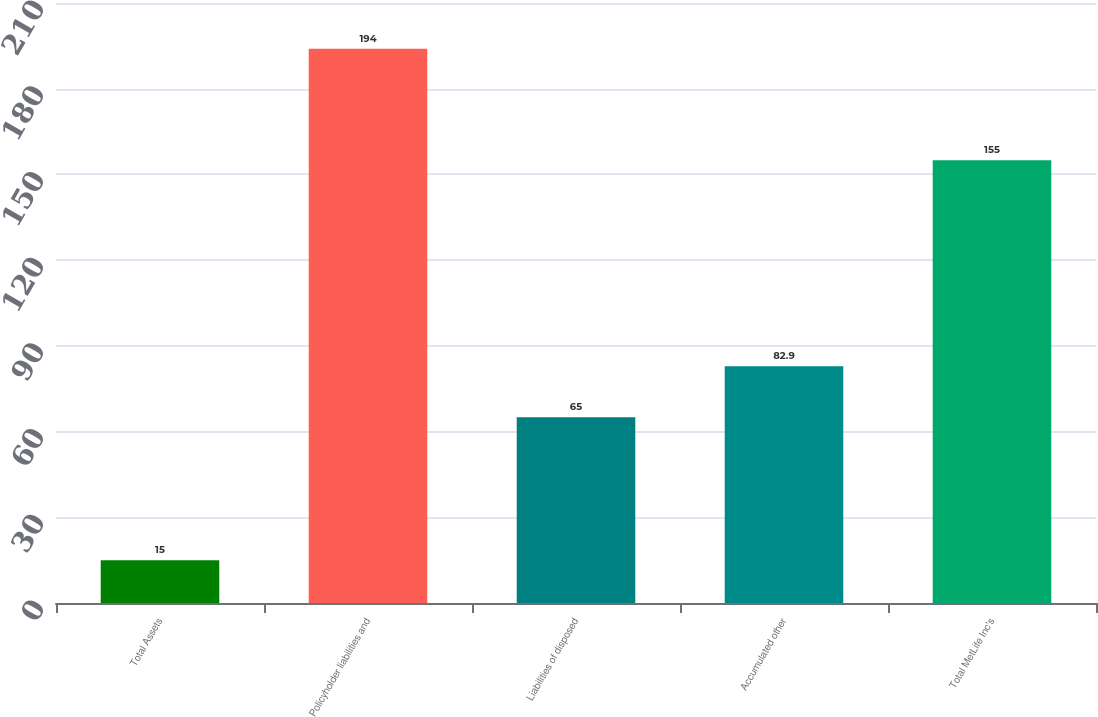Convert chart to OTSL. <chart><loc_0><loc_0><loc_500><loc_500><bar_chart><fcel>Total Assets<fcel>Policyholder liabilities and<fcel>Liabilities of disposed<fcel>Accumulated other<fcel>Total MetLife Inc's<nl><fcel>15<fcel>194<fcel>65<fcel>82.9<fcel>155<nl></chart> 